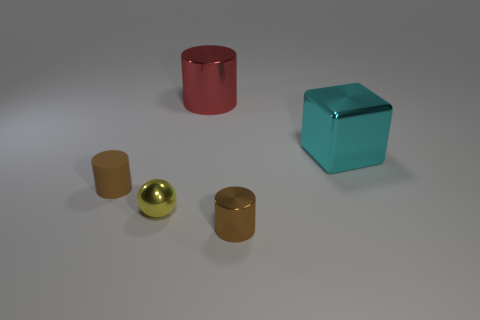Add 2 red cylinders. How many objects exist? 7 Subtract all cylinders. How many objects are left? 2 Add 3 gray cylinders. How many gray cylinders exist? 3 Subtract 0 gray cylinders. How many objects are left? 5 Subtract all small brown cylinders. Subtract all large blue rubber spheres. How many objects are left? 3 Add 2 small yellow shiny balls. How many small yellow shiny balls are left? 3 